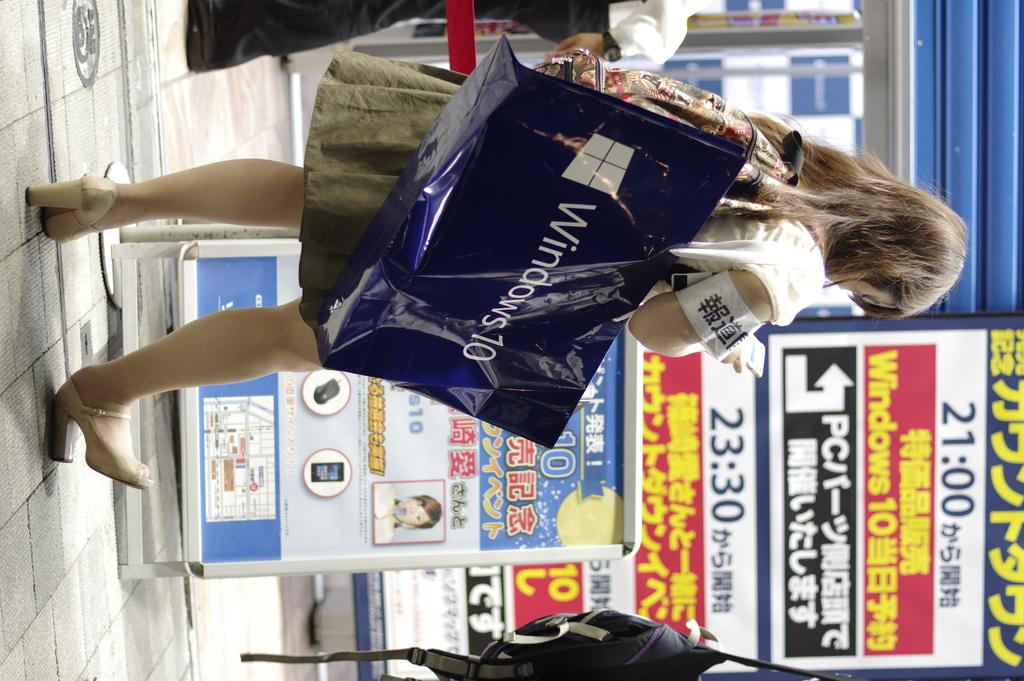<image>
Provide a brief description of the given image. A woman carrying a microsoft 10 bag outside stores with advertising on them. 